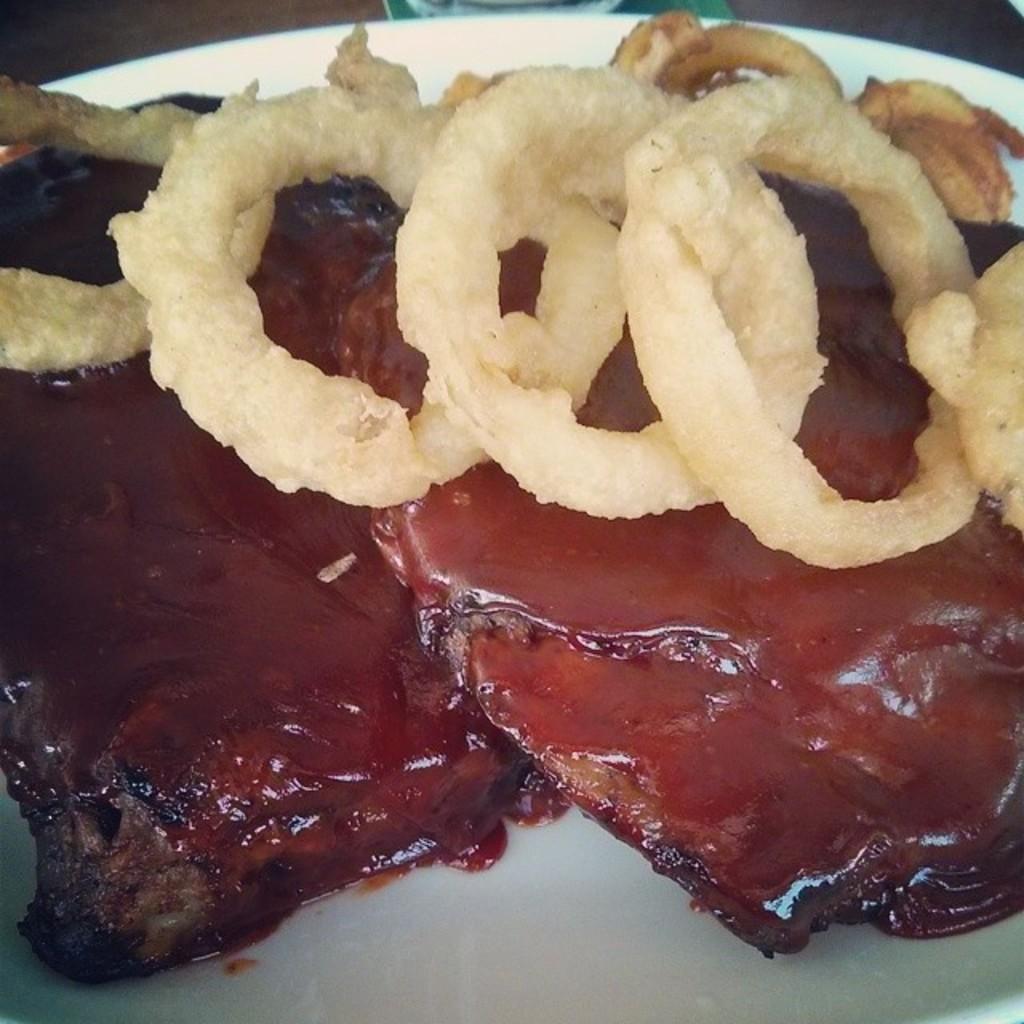In one or two sentences, can you explain what this image depicts? In this image I can see a white colored plate and in the plate I can see a food item which is brown and cream in color. 